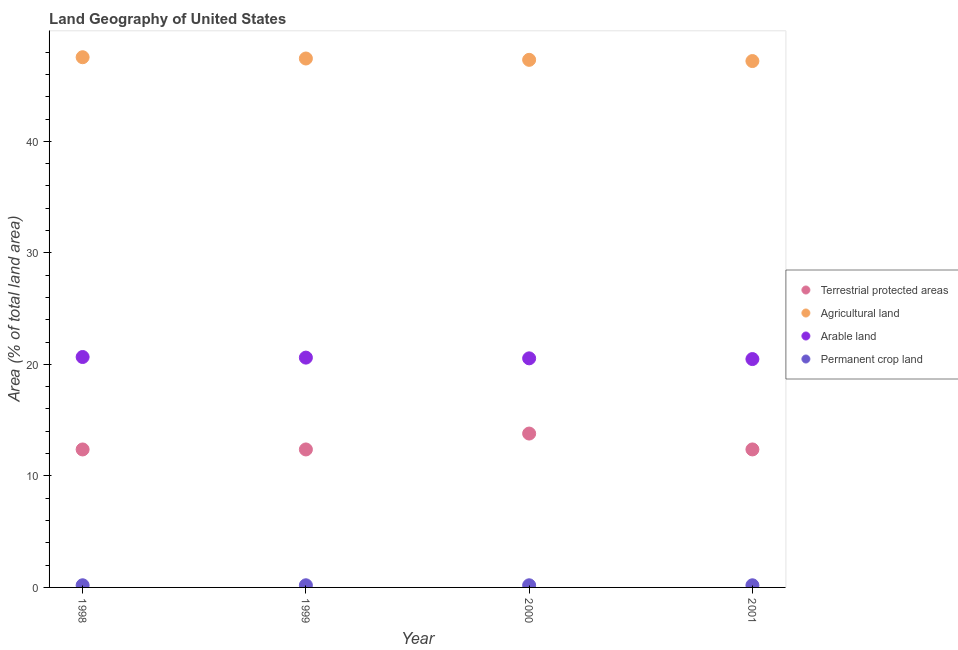How many different coloured dotlines are there?
Provide a succinct answer. 4. Is the number of dotlines equal to the number of legend labels?
Keep it short and to the point. Yes. What is the percentage of area under agricultural land in 2001?
Provide a succinct answer. 47.2. Across all years, what is the maximum percentage of land under terrestrial protection?
Your answer should be compact. 13.8. Across all years, what is the minimum percentage of area under permanent crop land?
Keep it short and to the point. 0.19. In which year was the percentage of area under agricultural land minimum?
Ensure brevity in your answer.  2001. What is the total percentage of area under permanent crop land in the graph?
Make the answer very short. 0.77. What is the difference between the percentage of land under terrestrial protection in 1998 and that in 2000?
Offer a very short reply. -1.43. What is the difference between the percentage of land under terrestrial protection in 2001 and the percentage of area under permanent crop land in 1999?
Offer a terse response. 12.18. What is the average percentage of area under agricultural land per year?
Keep it short and to the point. 47.37. In the year 1999, what is the difference between the percentage of area under permanent crop land and percentage of area under agricultural land?
Ensure brevity in your answer.  -47.24. What is the ratio of the percentage of area under permanent crop land in 1998 to that in 1999?
Your answer should be compact. 1. Is the percentage of land under terrestrial protection in 1999 less than that in 2000?
Your answer should be compact. Yes. Is the difference between the percentage of area under arable land in 1999 and 2000 greater than the difference between the percentage of area under agricultural land in 1999 and 2000?
Keep it short and to the point. No. What is the difference between the highest and the second highest percentage of area under agricultural land?
Your response must be concise. 0.11. What is the difference between the highest and the lowest percentage of area under agricultural land?
Your answer should be very brief. 0.34. Is it the case that in every year, the sum of the percentage of area under arable land and percentage of area under agricultural land is greater than the sum of percentage of land under terrestrial protection and percentage of area under permanent crop land?
Your answer should be very brief. No. Is the percentage of area under agricultural land strictly greater than the percentage of area under arable land over the years?
Your answer should be compact. Yes. How many dotlines are there?
Keep it short and to the point. 4. How many years are there in the graph?
Provide a short and direct response. 4. How many legend labels are there?
Provide a short and direct response. 4. How are the legend labels stacked?
Provide a succinct answer. Vertical. What is the title of the graph?
Ensure brevity in your answer.  Land Geography of United States. What is the label or title of the Y-axis?
Give a very brief answer. Area (% of total land area). What is the Area (% of total land area) of Terrestrial protected areas in 1998?
Your answer should be very brief. 12.37. What is the Area (% of total land area) in Agricultural land in 1998?
Give a very brief answer. 47.54. What is the Area (% of total land area) in Arable land in 1998?
Provide a short and direct response. 20.66. What is the Area (% of total land area) of Permanent crop land in 1998?
Offer a terse response. 0.19. What is the Area (% of total land area) of Terrestrial protected areas in 1999?
Make the answer very short. 12.37. What is the Area (% of total land area) of Agricultural land in 1999?
Provide a short and direct response. 47.43. What is the Area (% of total land area) of Arable land in 1999?
Your response must be concise. 20.61. What is the Area (% of total land area) of Permanent crop land in 1999?
Ensure brevity in your answer.  0.19. What is the Area (% of total land area) of Terrestrial protected areas in 2000?
Give a very brief answer. 13.8. What is the Area (% of total land area) in Agricultural land in 2000?
Ensure brevity in your answer.  47.31. What is the Area (% of total land area) of Arable land in 2000?
Offer a very short reply. 20.54. What is the Area (% of total land area) in Permanent crop land in 2000?
Provide a succinct answer. 0.19. What is the Area (% of total land area) in Terrestrial protected areas in 2001?
Your response must be concise. 12.37. What is the Area (% of total land area) in Agricultural land in 2001?
Your response must be concise. 47.2. What is the Area (% of total land area) of Arable land in 2001?
Offer a terse response. 20.48. What is the Area (% of total land area) in Permanent crop land in 2001?
Provide a short and direct response. 0.19. Across all years, what is the maximum Area (% of total land area) of Terrestrial protected areas?
Offer a very short reply. 13.8. Across all years, what is the maximum Area (% of total land area) in Agricultural land?
Keep it short and to the point. 47.54. Across all years, what is the maximum Area (% of total land area) in Arable land?
Ensure brevity in your answer.  20.66. Across all years, what is the maximum Area (% of total land area) of Permanent crop land?
Provide a succinct answer. 0.19. Across all years, what is the minimum Area (% of total land area) of Terrestrial protected areas?
Ensure brevity in your answer.  12.37. Across all years, what is the minimum Area (% of total land area) of Agricultural land?
Your answer should be compact. 47.2. Across all years, what is the minimum Area (% of total land area) of Arable land?
Make the answer very short. 20.48. Across all years, what is the minimum Area (% of total land area) in Permanent crop land?
Provide a short and direct response. 0.19. What is the total Area (% of total land area) of Terrestrial protected areas in the graph?
Give a very brief answer. 50.92. What is the total Area (% of total land area) in Agricultural land in the graph?
Keep it short and to the point. 189.48. What is the total Area (% of total land area) in Arable land in the graph?
Offer a very short reply. 82.29. What is the total Area (% of total land area) of Permanent crop land in the graph?
Your answer should be very brief. 0.77. What is the difference between the Area (% of total land area) of Terrestrial protected areas in 1998 and that in 1999?
Give a very brief answer. -0. What is the difference between the Area (% of total land area) in Agricultural land in 1998 and that in 1999?
Give a very brief answer. 0.11. What is the difference between the Area (% of total land area) in Arable land in 1998 and that in 1999?
Keep it short and to the point. 0.06. What is the difference between the Area (% of total land area) in Permanent crop land in 1998 and that in 1999?
Your answer should be compact. 0. What is the difference between the Area (% of total land area) in Terrestrial protected areas in 1998 and that in 2000?
Offer a terse response. -1.43. What is the difference between the Area (% of total land area) in Agricultural land in 1998 and that in 2000?
Give a very brief answer. 0.23. What is the difference between the Area (% of total land area) of Arable land in 1998 and that in 2000?
Provide a succinct answer. 0.12. What is the difference between the Area (% of total land area) of Permanent crop land in 1998 and that in 2000?
Ensure brevity in your answer.  0. What is the difference between the Area (% of total land area) in Terrestrial protected areas in 1998 and that in 2001?
Your response must be concise. -0. What is the difference between the Area (% of total land area) in Agricultural land in 1998 and that in 2001?
Provide a short and direct response. 0.34. What is the difference between the Area (% of total land area) in Arable land in 1998 and that in 2001?
Offer a terse response. 0.19. What is the difference between the Area (% of total land area) of Permanent crop land in 1998 and that in 2001?
Provide a succinct answer. 0. What is the difference between the Area (% of total land area) of Terrestrial protected areas in 1999 and that in 2000?
Keep it short and to the point. -1.43. What is the difference between the Area (% of total land area) of Agricultural land in 1999 and that in 2000?
Keep it short and to the point. 0.12. What is the difference between the Area (% of total land area) in Arable land in 1999 and that in 2000?
Provide a succinct answer. 0.07. What is the difference between the Area (% of total land area) of Terrestrial protected areas in 1999 and that in 2001?
Provide a succinct answer. -0. What is the difference between the Area (% of total land area) in Agricultural land in 1999 and that in 2001?
Keep it short and to the point. 0.23. What is the difference between the Area (% of total land area) of Arable land in 1999 and that in 2001?
Offer a very short reply. 0.13. What is the difference between the Area (% of total land area) of Permanent crop land in 1999 and that in 2001?
Your answer should be very brief. 0. What is the difference between the Area (% of total land area) of Terrestrial protected areas in 2000 and that in 2001?
Your response must be concise. 1.42. What is the difference between the Area (% of total land area) of Agricultural land in 2000 and that in 2001?
Provide a succinct answer. 0.11. What is the difference between the Area (% of total land area) of Arable land in 2000 and that in 2001?
Make the answer very short. 0.07. What is the difference between the Area (% of total land area) of Terrestrial protected areas in 1998 and the Area (% of total land area) of Agricultural land in 1999?
Provide a succinct answer. -35.06. What is the difference between the Area (% of total land area) of Terrestrial protected areas in 1998 and the Area (% of total land area) of Arable land in 1999?
Your answer should be very brief. -8.23. What is the difference between the Area (% of total land area) in Terrestrial protected areas in 1998 and the Area (% of total land area) in Permanent crop land in 1999?
Give a very brief answer. 12.18. What is the difference between the Area (% of total land area) in Agricultural land in 1998 and the Area (% of total land area) in Arable land in 1999?
Keep it short and to the point. 26.94. What is the difference between the Area (% of total land area) in Agricultural land in 1998 and the Area (% of total land area) in Permanent crop land in 1999?
Make the answer very short. 47.35. What is the difference between the Area (% of total land area) in Arable land in 1998 and the Area (% of total land area) in Permanent crop land in 1999?
Keep it short and to the point. 20.47. What is the difference between the Area (% of total land area) in Terrestrial protected areas in 1998 and the Area (% of total land area) in Agricultural land in 2000?
Provide a succinct answer. -34.94. What is the difference between the Area (% of total land area) of Terrestrial protected areas in 1998 and the Area (% of total land area) of Arable land in 2000?
Provide a succinct answer. -8.17. What is the difference between the Area (% of total land area) of Terrestrial protected areas in 1998 and the Area (% of total land area) of Permanent crop land in 2000?
Provide a succinct answer. 12.18. What is the difference between the Area (% of total land area) of Agricultural land in 1998 and the Area (% of total land area) of Arable land in 2000?
Your response must be concise. 27. What is the difference between the Area (% of total land area) in Agricultural land in 1998 and the Area (% of total land area) in Permanent crop land in 2000?
Offer a terse response. 47.35. What is the difference between the Area (% of total land area) of Arable land in 1998 and the Area (% of total land area) of Permanent crop land in 2000?
Your answer should be very brief. 20.47. What is the difference between the Area (% of total land area) in Terrestrial protected areas in 1998 and the Area (% of total land area) in Agricultural land in 2001?
Ensure brevity in your answer.  -34.83. What is the difference between the Area (% of total land area) in Terrestrial protected areas in 1998 and the Area (% of total land area) in Arable land in 2001?
Offer a terse response. -8.1. What is the difference between the Area (% of total land area) of Terrestrial protected areas in 1998 and the Area (% of total land area) of Permanent crop land in 2001?
Your response must be concise. 12.18. What is the difference between the Area (% of total land area) of Agricultural land in 1998 and the Area (% of total land area) of Arable land in 2001?
Make the answer very short. 27.07. What is the difference between the Area (% of total land area) of Agricultural land in 1998 and the Area (% of total land area) of Permanent crop land in 2001?
Your answer should be compact. 47.35. What is the difference between the Area (% of total land area) of Arable land in 1998 and the Area (% of total land area) of Permanent crop land in 2001?
Your answer should be compact. 20.47. What is the difference between the Area (% of total land area) of Terrestrial protected areas in 1999 and the Area (% of total land area) of Agricultural land in 2000?
Make the answer very short. -34.94. What is the difference between the Area (% of total land area) in Terrestrial protected areas in 1999 and the Area (% of total land area) in Arable land in 2000?
Your answer should be compact. -8.17. What is the difference between the Area (% of total land area) of Terrestrial protected areas in 1999 and the Area (% of total land area) of Permanent crop land in 2000?
Your answer should be very brief. 12.18. What is the difference between the Area (% of total land area) of Agricultural land in 1999 and the Area (% of total land area) of Arable land in 2000?
Ensure brevity in your answer.  26.89. What is the difference between the Area (% of total land area) of Agricultural land in 1999 and the Area (% of total land area) of Permanent crop land in 2000?
Your response must be concise. 47.24. What is the difference between the Area (% of total land area) of Arable land in 1999 and the Area (% of total land area) of Permanent crop land in 2000?
Offer a very short reply. 20.41. What is the difference between the Area (% of total land area) in Terrestrial protected areas in 1999 and the Area (% of total land area) in Agricultural land in 2001?
Offer a very short reply. -34.83. What is the difference between the Area (% of total land area) in Terrestrial protected areas in 1999 and the Area (% of total land area) in Arable land in 2001?
Your answer should be compact. -8.1. What is the difference between the Area (% of total land area) in Terrestrial protected areas in 1999 and the Area (% of total land area) in Permanent crop land in 2001?
Provide a succinct answer. 12.18. What is the difference between the Area (% of total land area) in Agricultural land in 1999 and the Area (% of total land area) in Arable land in 2001?
Offer a terse response. 26.95. What is the difference between the Area (% of total land area) of Agricultural land in 1999 and the Area (% of total land area) of Permanent crop land in 2001?
Your answer should be very brief. 47.24. What is the difference between the Area (% of total land area) in Arable land in 1999 and the Area (% of total land area) in Permanent crop land in 2001?
Give a very brief answer. 20.41. What is the difference between the Area (% of total land area) of Terrestrial protected areas in 2000 and the Area (% of total land area) of Agricultural land in 2001?
Provide a succinct answer. -33.4. What is the difference between the Area (% of total land area) in Terrestrial protected areas in 2000 and the Area (% of total land area) in Arable land in 2001?
Keep it short and to the point. -6.68. What is the difference between the Area (% of total land area) in Terrestrial protected areas in 2000 and the Area (% of total land area) in Permanent crop land in 2001?
Offer a very short reply. 13.61. What is the difference between the Area (% of total land area) of Agricultural land in 2000 and the Area (% of total land area) of Arable land in 2001?
Provide a succinct answer. 26.83. What is the difference between the Area (% of total land area) in Agricultural land in 2000 and the Area (% of total land area) in Permanent crop land in 2001?
Ensure brevity in your answer.  47.12. What is the difference between the Area (% of total land area) in Arable land in 2000 and the Area (% of total land area) in Permanent crop land in 2001?
Ensure brevity in your answer.  20.35. What is the average Area (% of total land area) in Terrestrial protected areas per year?
Provide a short and direct response. 12.73. What is the average Area (% of total land area) in Agricultural land per year?
Ensure brevity in your answer.  47.37. What is the average Area (% of total land area) in Arable land per year?
Your answer should be very brief. 20.57. What is the average Area (% of total land area) of Permanent crop land per year?
Provide a short and direct response. 0.19. In the year 1998, what is the difference between the Area (% of total land area) in Terrestrial protected areas and Area (% of total land area) in Agricultural land?
Your answer should be very brief. -35.17. In the year 1998, what is the difference between the Area (% of total land area) of Terrestrial protected areas and Area (% of total land area) of Arable land?
Ensure brevity in your answer.  -8.29. In the year 1998, what is the difference between the Area (% of total land area) in Terrestrial protected areas and Area (% of total land area) in Permanent crop land?
Keep it short and to the point. 12.18. In the year 1998, what is the difference between the Area (% of total land area) of Agricultural land and Area (% of total land area) of Arable land?
Make the answer very short. 26.88. In the year 1998, what is the difference between the Area (% of total land area) in Agricultural land and Area (% of total land area) in Permanent crop land?
Your answer should be compact. 47.35. In the year 1998, what is the difference between the Area (% of total land area) in Arable land and Area (% of total land area) in Permanent crop land?
Offer a very short reply. 20.47. In the year 1999, what is the difference between the Area (% of total land area) of Terrestrial protected areas and Area (% of total land area) of Agricultural land?
Ensure brevity in your answer.  -35.06. In the year 1999, what is the difference between the Area (% of total land area) in Terrestrial protected areas and Area (% of total land area) in Arable land?
Your answer should be compact. -8.23. In the year 1999, what is the difference between the Area (% of total land area) in Terrestrial protected areas and Area (% of total land area) in Permanent crop land?
Your answer should be compact. 12.18. In the year 1999, what is the difference between the Area (% of total land area) in Agricultural land and Area (% of total land area) in Arable land?
Your answer should be very brief. 26.82. In the year 1999, what is the difference between the Area (% of total land area) in Agricultural land and Area (% of total land area) in Permanent crop land?
Offer a terse response. 47.24. In the year 1999, what is the difference between the Area (% of total land area) in Arable land and Area (% of total land area) in Permanent crop land?
Offer a very short reply. 20.41. In the year 2000, what is the difference between the Area (% of total land area) of Terrestrial protected areas and Area (% of total land area) of Agricultural land?
Offer a very short reply. -33.51. In the year 2000, what is the difference between the Area (% of total land area) of Terrestrial protected areas and Area (% of total land area) of Arable land?
Offer a very short reply. -6.74. In the year 2000, what is the difference between the Area (% of total land area) in Terrestrial protected areas and Area (% of total land area) in Permanent crop land?
Make the answer very short. 13.61. In the year 2000, what is the difference between the Area (% of total land area) in Agricultural land and Area (% of total land area) in Arable land?
Offer a very short reply. 26.77. In the year 2000, what is the difference between the Area (% of total land area) in Agricultural land and Area (% of total land area) in Permanent crop land?
Offer a terse response. 47.12. In the year 2000, what is the difference between the Area (% of total land area) in Arable land and Area (% of total land area) in Permanent crop land?
Provide a succinct answer. 20.35. In the year 2001, what is the difference between the Area (% of total land area) of Terrestrial protected areas and Area (% of total land area) of Agricultural land?
Your answer should be very brief. -34.83. In the year 2001, what is the difference between the Area (% of total land area) in Terrestrial protected areas and Area (% of total land area) in Arable land?
Your answer should be compact. -8.1. In the year 2001, what is the difference between the Area (% of total land area) in Terrestrial protected areas and Area (% of total land area) in Permanent crop land?
Offer a terse response. 12.18. In the year 2001, what is the difference between the Area (% of total land area) in Agricultural land and Area (% of total land area) in Arable land?
Keep it short and to the point. 26.72. In the year 2001, what is the difference between the Area (% of total land area) in Agricultural land and Area (% of total land area) in Permanent crop land?
Offer a very short reply. 47.01. In the year 2001, what is the difference between the Area (% of total land area) of Arable land and Area (% of total land area) of Permanent crop land?
Ensure brevity in your answer.  20.29. What is the ratio of the Area (% of total land area) of Terrestrial protected areas in 1998 to that in 2000?
Keep it short and to the point. 0.9. What is the ratio of the Area (% of total land area) of Agricultural land in 1998 to that in 2000?
Keep it short and to the point. 1. What is the ratio of the Area (% of total land area) in Arable land in 1998 to that in 2000?
Provide a short and direct response. 1.01. What is the ratio of the Area (% of total land area) of Terrestrial protected areas in 1998 to that in 2001?
Your answer should be very brief. 1. What is the ratio of the Area (% of total land area) in Agricultural land in 1998 to that in 2001?
Make the answer very short. 1.01. What is the ratio of the Area (% of total land area) of Arable land in 1998 to that in 2001?
Keep it short and to the point. 1.01. What is the ratio of the Area (% of total land area) in Permanent crop land in 1998 to that in 2001?
Provide a succinct answer. 1.01. What is the ratio of the Area (% of total land area) of Terrestrial protected areas in 1999 to that in 2000?
Ensure brevity in your answer.  0.9. What is the ratio of the Area (% of total land area) of Agricultural land in 1999 to that in 2001?
Provide a succinct answer. 1. What is the ratio of the Area (% of total land area) of Arable land in 1999 to that in 2001?
Your answer should be compact. 1.01. What is the ratio of the Area (% of total land area) in Terrestrial protected areas in 2000 to that in 2001?
Offer a very short reply. 1.11. What is the ratio of the Area (% of total land area) of Arable land in 2000 to that in 2001?
Give a very brief answer. 1. What is the difference between the highest and the second highest Area (% of total land area) of Terrestrial protected areas?
Ensure brevity in your answer.  1.42. What is the difference between the highest and the second highest Area (% of total land area) of Agricultural land?
Offer a terse response. 0.11. What is the difference between the highest and the second highest Area (% of total land area) of Arable land?
Provide a short and direct response. 0.06. What is the difference between the highest and the lowest Area (% of total land area) of Terrestrial protected areas?
Make the answer very short. 1.43. What is the difference between the highest and the lowest Area (% of total land area) in Agricultural land?
Your answer should be compact. 0.34. What is the difference between the highest and the lowest Area (% of total land area) in Arable land?
Offer a terse response. 0.19. What is the difference between the highest and the lowest Area (% of total land area) of Permanent crop land?
Make the answer very short. 0. 